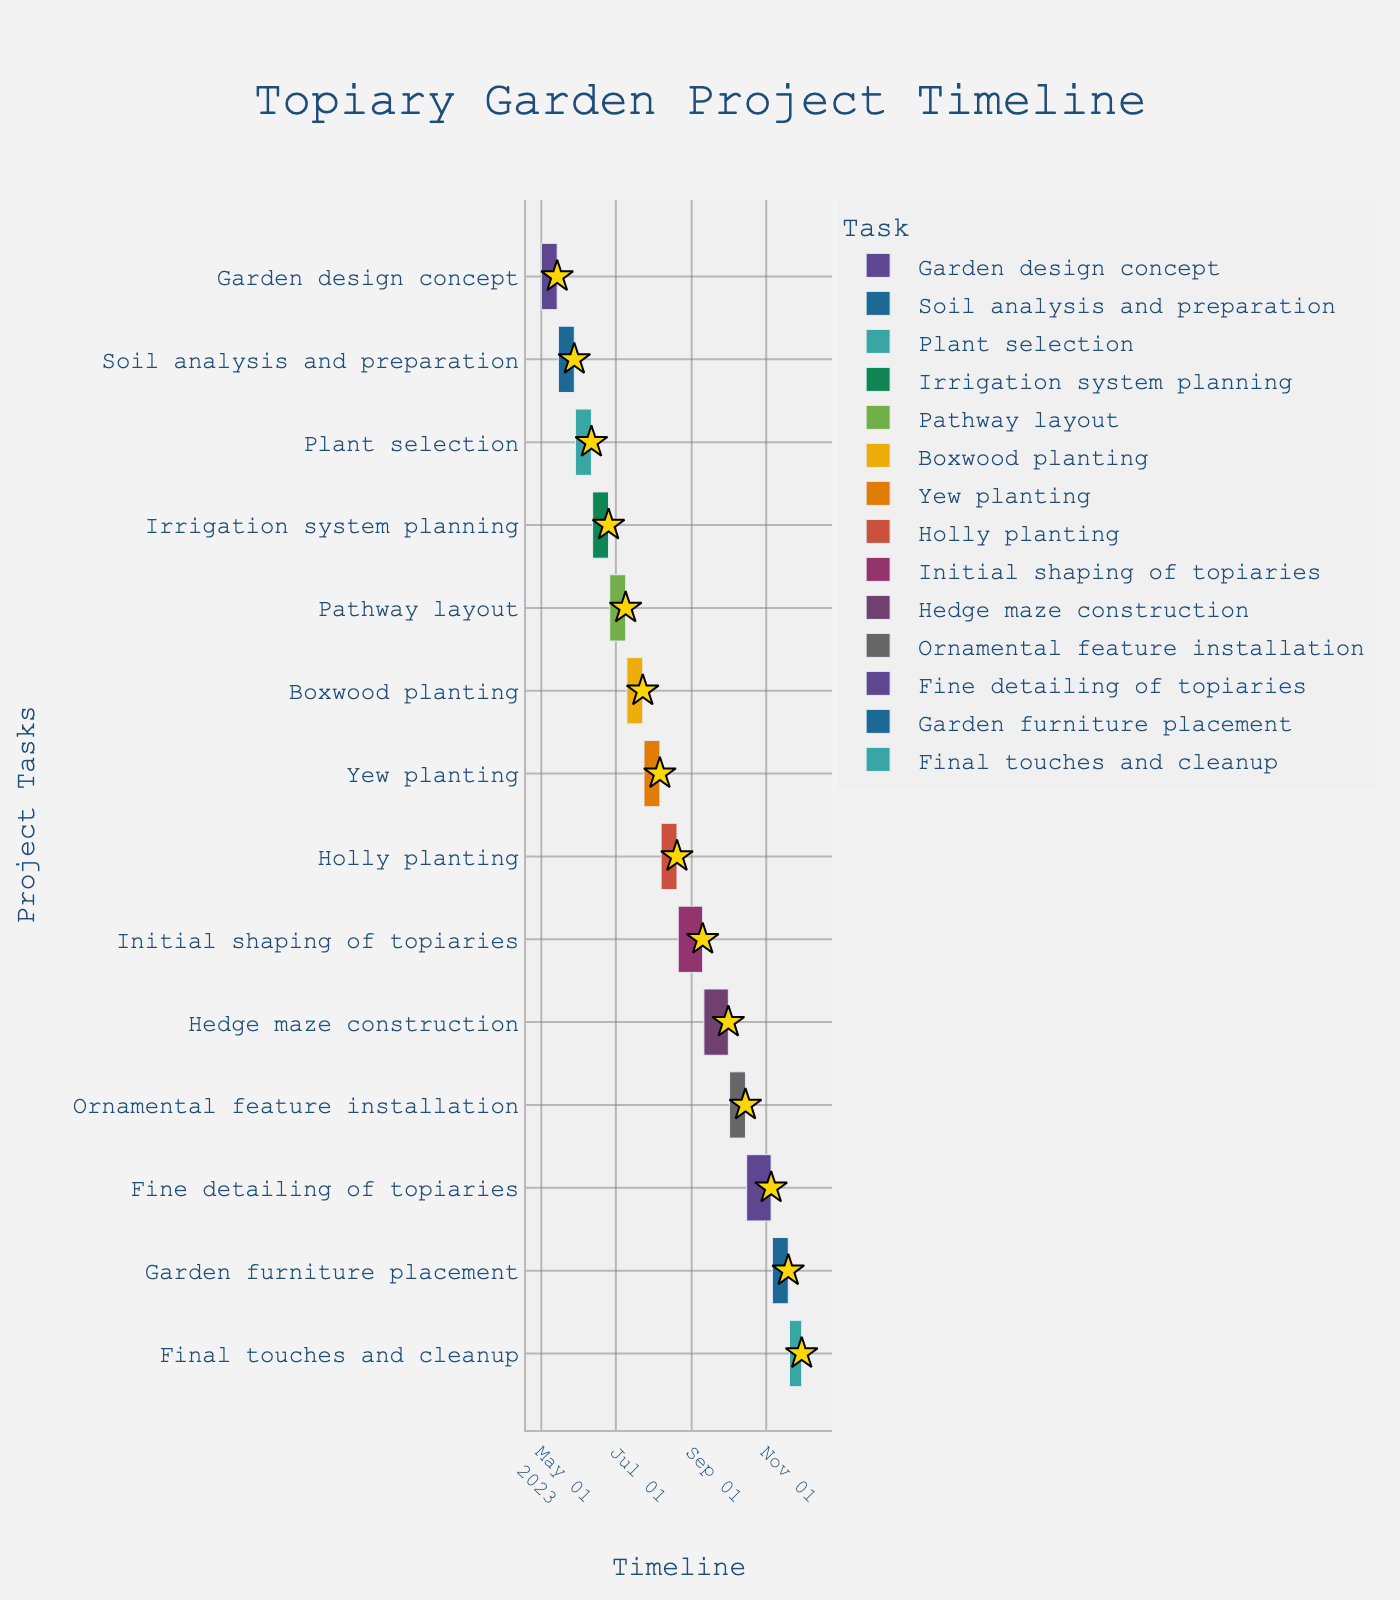What is the title of the Gantt Chart? The title of the Gantt Chart is written at the top center of the figure. It provides an overview of what the Gantt Chart represents.
Answer: Topiary Garden Project Timeline Which phase starts immediately after the Garden design concept? Inspecting the timeline, the phase that starts right after the Garden design concept is the next one listed in chronological order.
Answer: Soil analysis and preparation How long does the Pathway layout phase last? The Pathway layout phase starts on 2023-06-26 and ends on 2023-07-09. Subtract the start date from the end date to determine the duration.
Answer: 14 days Compare the duration of Boxwood planting and Yew planting. Which one takes more time? Boxwood planting lasts from 2023-07-10 to 2023-07-23, whereas Yew planting lasts from 2023-07-24 to 2023-08-06. Both tasks have a similar duration.
Answer: They take the same amount of time What is the overall time span of the topiary garden project? The entire project starts on 2023-05-01 and ends on 2023-11-30. Calculate the difference between these two dates to get the total project duration.
Answer: 214 days During which month is the Initial shaping of topiaries mostly conducted? The Initial shaping of topiaries happens from 2023-08-21 to 2023-09-10. Observing the timeline, most of the work falls within August.
Answer: August Identify the task with the shortest duration. By examining the duration of all tasks, the one with the shortest span will be identified. Ornamental feature installation lasts only from 2023-10-02 to 2023-10-15.
Answer: Ornamental feature installation Are there any gap periods between tasks in the project timeline? Review the dates for any gaps where there is no overlapping or consecutive task starting immediately after another ends.
Answer: No, there are no gaps What is the duration difference between the Initial shaping of topiaries and Fine detailing of topiaries? Calculate the duration of each task, then find the difference between them. Initial shaping occurs from 2023-08-21 to 2023-09-10 (21 days), and Fine detailing happens from 2023-10-16 to 2023-11-05 (21 days).
Answer: 0 days During which phase of the project is the duration longest? Compare the duration of all tasks listed to identify the task with the longest duration. Hedge maze construction lasts from 2023-09-11 to 2023-10-01.
Answer: Hedge maze construction 